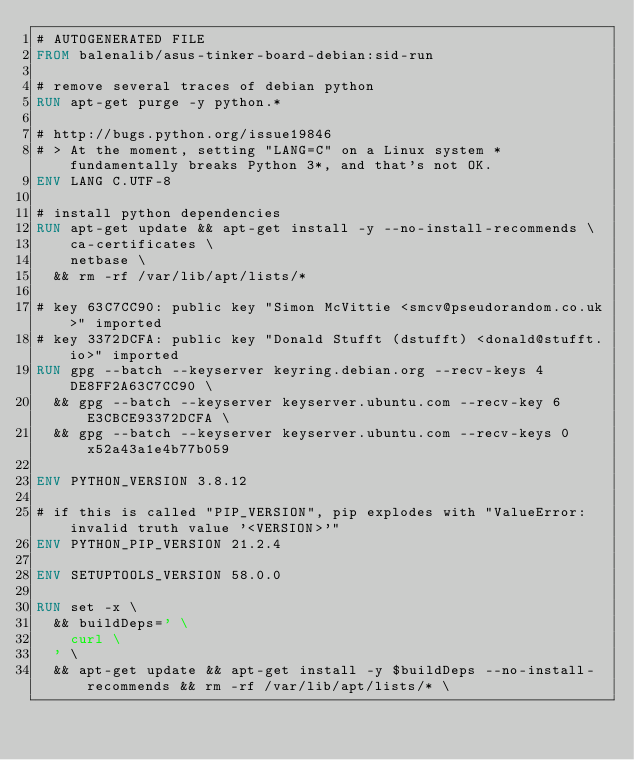Convert code to text. <code><loc_0><loc_0><loc_500><loc_500><_Dockerfile_># AUTOGENERATED FILE
FROM balenalib/asus-tinker-board-debian:sid-run

# remove several traces of debian python
RUN apt-get purge -y python.*

# http://bugs.python.org/issue19846
# > At the moment, setting "LANG=C" on a Linux system *fundamentally breaks Python 3*, and that's not OK.
ENV LANG C.UTF-8

# install python dependencies
RUN apt-get update && apt-get install -y --no-install-recommends \
		ca-certificates \
		netbase \
	&& rm -rf /var/lib/apt/lists/*

# key 63C7CC90: public key "Simon McVittie <smcv@pseudorandom.co.uk>" imported
# key 3372DCFA: public key "Donald Stufft (dstufft) <donald@stufft.io>" imported
RUN gpg --batch --keyserver keyring.debian.org --recv-keys 4DE8FF2A63C7CC90 \
	&& gpg --batch --keyserver keyserver.ubuntu.com --recv-key 6E3CBCE93372DCFA \
	&& gpg --batch --keyserver keyserver.ubuntu.com --recv-keys 0x52a43a1e4b77b059

ENV PYTHON_VERSION 3.8.12

# if this is called "PIP_VERSION", pip explodes with "ValueError: invalid truth value '<VERSION>'"
ENV PYTHON_PIP_VERSION 21.2.4

ENV SETUPTOOLS_VERSION 58.0.0

RUN set -x \
	&& buildDeps=' \
		curl \
	' \
	&& apt-get update && apt-get install -y $buildDeps --no-install-recommends && rm -rf /var/lib/apt/lists/* \</code> 